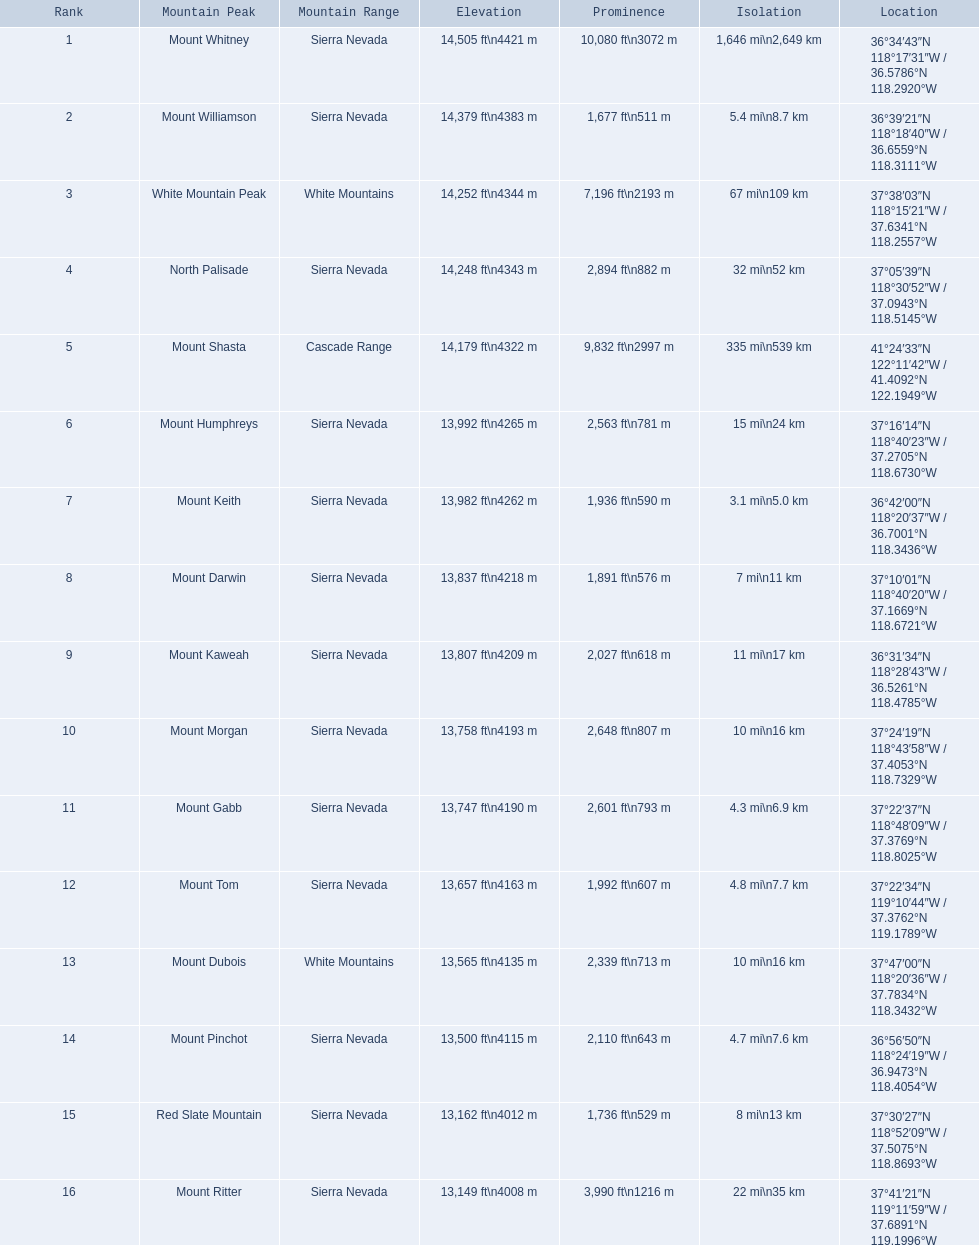Which are the mountain peaks? Mount Whitney, Mount Williamson, White Mountain Peak, North Palisade, Mount Shasta, Mount Humphreys, Mount Keith, Mount Darwin, Mount Kaweah, Mount Morgan, Mount Gabb, Mount Tom, Mount Dubois, Mount Pinchot, Red Slate Mountain, Mount Ritter. Of these, which is in the cascade range? Mount Shasta. What are the mountain peaks in california? Mount Whitney, Mount Williamson, White Mountain Peak, North Palisade, Mount Shasta, Mount Humphreys, Mount Keith, Mount Darwin, Mount Kaweah, Mount Morgan, Mount Gabb, Mount Tom, Mount Dubois, Mount Pinchot, Red Slate Mountain, Mount Ritter. What are the mountain peaks in sierra nevada, california? Mount Whitney, Mount Williamson, North Palisade, Mount Humphreys, Mount Keith, Mount Darwin, Mount Kaweah, Mount Morgan, Mount Gabb, Mount Tom, Mount Pinchot, Red Slate Mountain, Mount Ritter. What are the altitudes of the peaks in sierra nevada? 14,505 ft\n4421 m, 14,379 ft\n4383 m, 14,248 ft\n4343 m, 13,992 ft\n4265 m, 13,982 ft\n4262 m, 13,837 ft\n4218 m, 13,807 ft\n4209 m, 13,758 ft\n4193 m, 13,747 ft\n4190 m, 13,657 ft\n4163 m, 13,500 ft\n4115 m, 13,162 ft\n4012 m, 13,149 ft\n4008 m. Which one has the greatest elevation? Mount Whitney. 